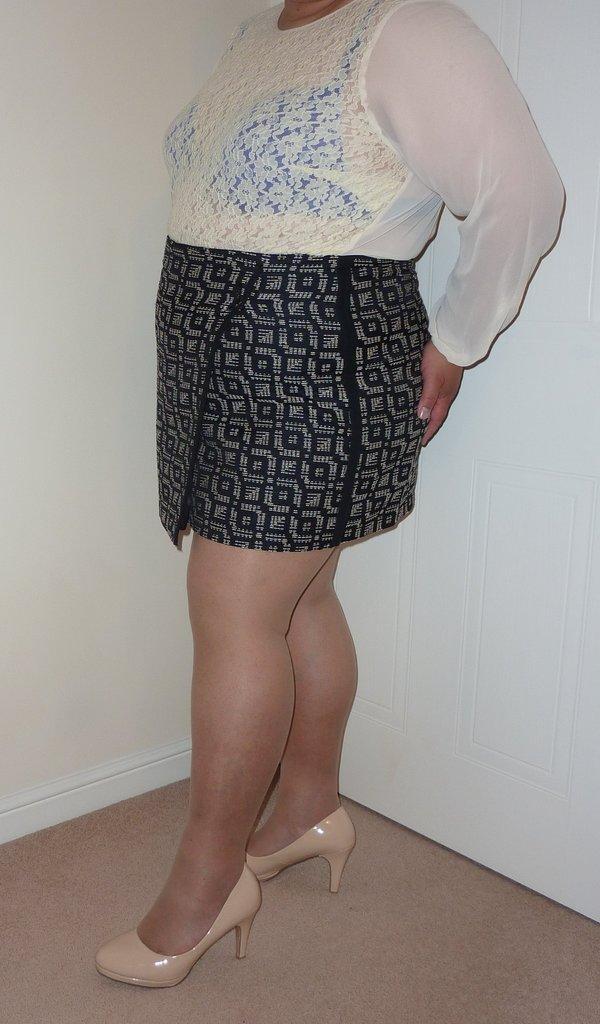Could you give a brief overview of what you see in this image? In this picture we can see a woman wore sandals and standing on the floor and at the back of her we can see a door and in the background we can see the wall. 